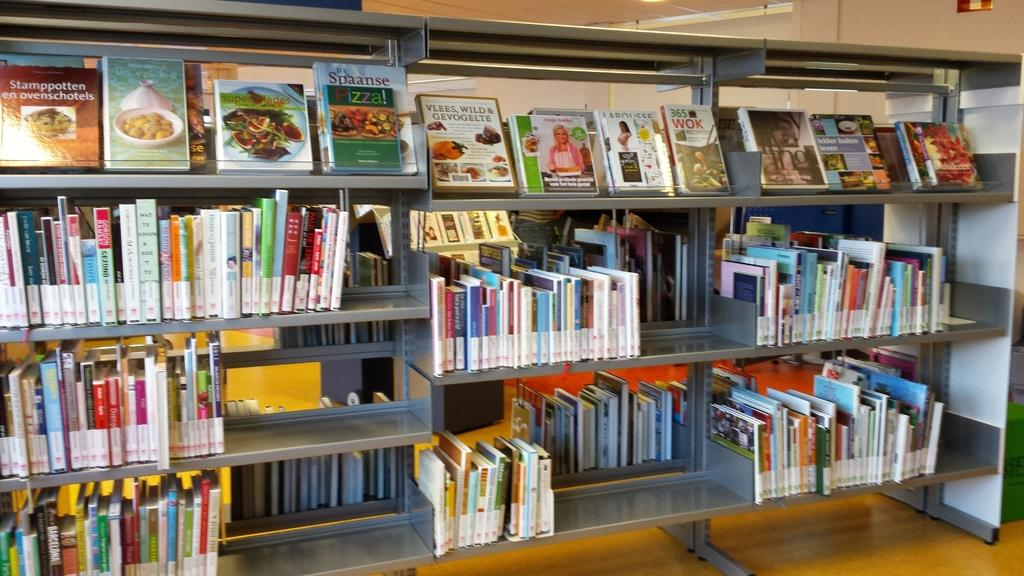<image>
Render a clear and concise summary of the photo. Shelves of books are on display with the upper left book titled Stamppotten en ovenschotels. 